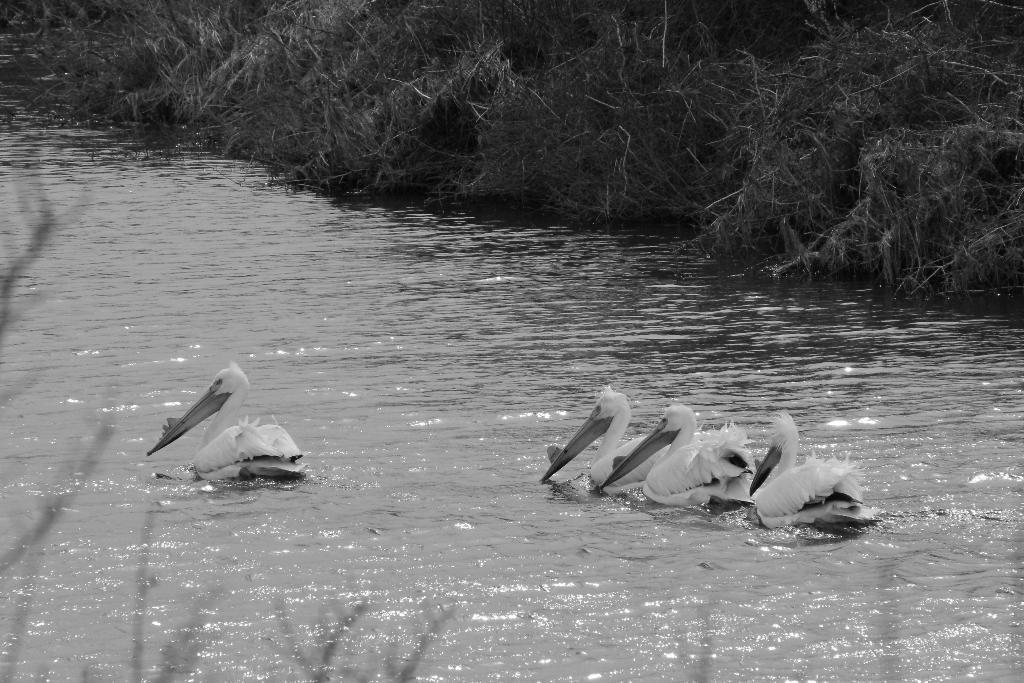What is the color scheme of the image? The image is black and white. What animals can be seen in the image? There are birds in the water. What type of vegetation is visible at the top of the image? There is grass visible at the top of the image. Where is the mailbox located in the image? There is no mailbox present in the image. What type of experience can be gained from the picture? The image is a still photograph, so it does not offer an experience in the traditional sense. 